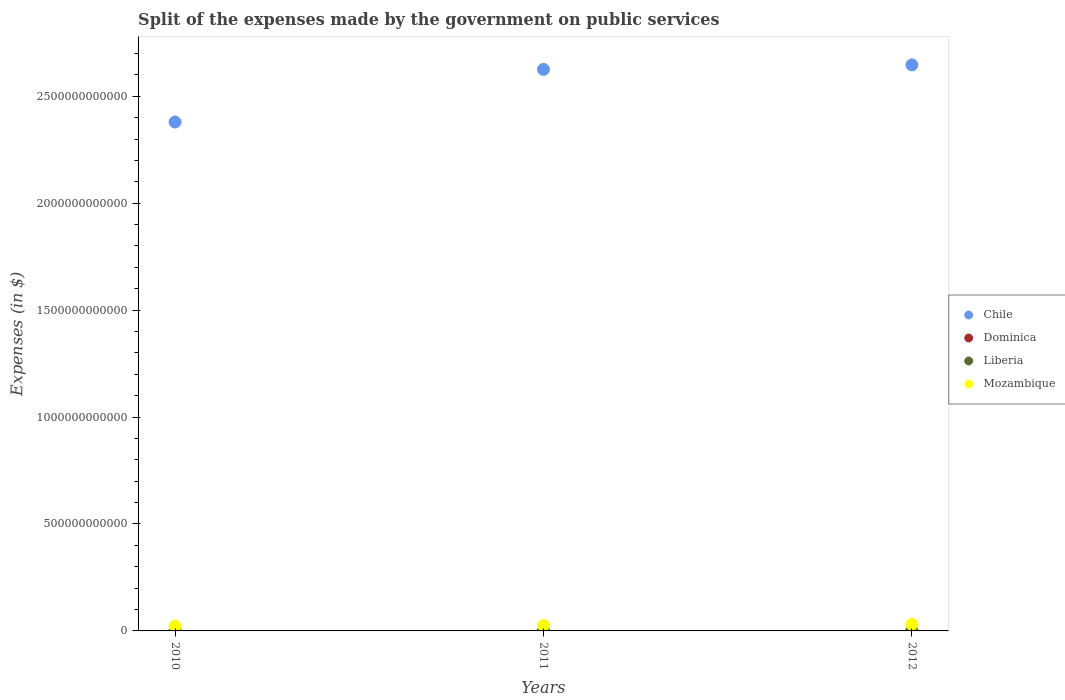Is the number of dotlines equal to the number of legend labels?
Offer a very short reply. Yes. What is the expenses made by the government on public services in Chile in 2012?
Offer a very short reply. 2.65e+12. Across all years, what is the maximum expenses made by the government on public services in Chile?
Give a very brief answer. 2.65e+12. Across all years, what is the minimum expenses made by the government on public services in Dominica?
Your answer should be compact. 9.19e+07. In which year was the expenses made by the government on public services in Dominica maximum?
Provide a succinct answer. 2010. What is the total expenses made by the government on public services in Dominica in the graph?
Provide a succinct answer. 2.88e+08. What is the difference between the expenses made by the government on public services in Mozambique in 2010 and that in 2012?
Your answer should be very brief. -8.15e+09. What is the difference between the expenses made by the government on public services in Liberia in 2011 and the expenses made by the government on public services in Chile in 2010?
Your response must be concise. -2.38e+12. What is the average expenses made by the government on public services in Dominica per year?
Give a very brief answer. 9.62e+07. In the year 2011, what is the difference between the expenses made by the government on public services in Chile and expenses made by the government on public services in Liberia?
Make the answer very short. 2.63e+12. In how many years, is the expenses made by the government on public services in Mozambique greater than 500000000000 $?
Your answer should be compact. 0. What is the ratio of the expenses made by the government on public services in Liberia in 2010 to that in 2011?
Your response must be concise. 0.83. Is the expenses made by the government on public services in Dominica in 2010 less than that in 2012?
Ensure brevity in your answer.  No. What is the difference between the highest and the second highest expenses made by the government on public services in Dominica?
Keep it short and to the point. 2.00e+06. What is the difference between the highest and the lowest expenses made by the government on public services in Liberia?
Keep it short and to the point. 6.64e+05. In how many years, is the expenses made by the government on public services in Liberia greater than the average expenses made by the government on public services in Liberia taken over all years?
Your answer should be compact. 1. Is it the case that in every year, the sum of the expenses made by the government on public services in Mozambique and expenses made by the government on public services in Chile  is greater than the sum of expenses made by the government on public services in Dominica and expenses made by the government on public services in Liberia?
Make the answer very short. Yes. Does the expenses made by the government on public services in Chile monotonically increase over the years?
Give a very brief answer. Yes. Is the expenses made by the government on public services in Chile strictly greater than the expenses made by the government on public services in Liberia over the years?
Make the answer very short. Yes. Is the expenses made by the government on public services in Liberia strictly less than the expenses made by the government on public services in Mozambique over the years?
Your answer should be very brief. Yes. How many dotlines are there?
Give a very brief answer. 4. How many years are there in the graph?
Make the answer very short. 3. What is the difference between two consecutive major ticks on the Y-axis?
Offer a terse response. 5.00e+11. Does the graph contain grids?
Offer a very short reply. No. Where does the legend appear in the graph?
Keep it short and to the point. Center right. How many legend labels are there?
Offer a terse response. 4. What is the title of the graph?
Your answer should be very brief. Split of the expenses made by the government on public services. Does "Fragile and conflict affected situations" appear as one of the legend labels in the graph?
Make the answer very short. No. What is the label or title of the Y-axis?
Offer a terse response. Expenses (in $). What is the Expenses (in $) of Chile in 2010?
Provide a succinct answer. 2.38e+12. What is the Expenses (in $) in Dominica in 2010?
Ensure brevity in your answer.  9.93e+07. What is the Expenses (in $) of Liberia in 2010?
Offer a terse response. 9.82e+05. What is the Expenses (in $) of Mozambique in 2010?
Your answer should be very brief. 2.24e+1. What is the Expenses (in $) in Chile in 2011?
Provide a short and direct response. 2.63e+12. What is the Expenses (in $) in Dominica in 2011?
Your response must be concise. 9.73e+07. What is the Expenses (in $) of Liberia in 2011?
Give a very brief answer. 1.19e+06. What is the Expenses (in $) in Mozambique in 2011?
Keep it short and to the point. 2.52e+1. What is the Expenses (in $) in Chile in 2012?
Make the answer very short. 2.65e+12. What is the Expenses (in $) in Dominica in 2012?
Offer a very short reply. 9.19e+07. What is the Expenses (in $) of Liberia in 2012?
Your answer should be compact. 1.65e+06. What is the Expenses (in $) of Mozambique in 2012?
Give a very brief answer. 3.05e+1. Across all years, what is the maximum Expenses (in $) of Chile?
Offer a terse response. 2.65e+12. Across all years, what is the maximum Expenses (in $) of Dominica?
Provide a short and direct response. 9.93e+07. Across all years, what is the maximum Expenses (in $) of Liberia?
Give a very brief answer. 1.65e+06. Across all years, what is the maximum Expenses (in $) in Mozambique?
Provide a succinct answer. 3.05e+1. Across all years, what is the minimum Expenses (in $) in Chile?
Your answer should be compact. 2.38e+12. Across all years, what is the minimum Expenses (in $) of Dominica?
Give a very brief answer. 9.19e+07. Across all years, what is the minimum Expenses (in $) of Liberia?
Offer a very short reply. 9.82e+05. Across all years, what is the minimum Expenses (in $) of Mozambique?
Offer a terse response. 2.24e+1. What is the total Expenses (in $) of Chile in the graph?
Your answer should be very brief. 7.65e+12. What is the total Expenses (in $) of Dominica in the graph?
Provide a succinct answer. 2.88e+08. What is the total Expenses (in $) in Liberia in the graph?
Ensure brevity in your answer.  3.81e+06. What is the total Expenses (in $) of Mozambique in the graph?
Provide a succinct answer. 7.81e+1. What is the difference between the Expenses (in $) of Chile in 2010 and that in 2011?
Offer a very short reply. -2.46e+11. What is the difference between the Expenses (in $) of Dominica in 2010 and that in 2011?
Give a very brief answer. 2.00e+06. What is the difference between the Expenses (in $) in Liberia in 2010 and that in 2011?
Offer a very short reply. -2.03e+05. What is the difference between the Expenses (in $) of Mozambique in 2010 and that in 2011?
Your response must be concise. -2.84e+09. What is the difference between the Expenses (in $) of Chile in 2010 and that in 2012?
Provide a short and direct response. -2.67e+11. What is the difference between the Expenses (in $) in Dominica in 2010 and that in 2012?
Make the answer very short. 7.40e+06. What is the difference between the Expenses (in $) of Liberia in 2010 and that in 2012?
Offer a very short reply. -6.64e+05. What is the difference between the Expenses (in $) of Mozambique in 2010 and that in 2012?
Offer a very short reply. -8.15e+09. What is the difference between the Expenses (in $) in Chile in 2011 and that in 2012?
Your response must be concise. -2.11e+1. What is the difference between the Expenses (in $) in Dominica in 2011 and that in 2012?
Make the answer very short. 5.40e+06. What is the difference between the Expenses (in $) of Liberia in 2011 and that in 2012?
Offer a terse response. -4.61e+05. What is the difference between the Expenses (in $) in Mozambique in 2011 and that in 2012?
Your response must be concise. -5.32e+09. What is the difference between the Expenses (in $) in Chile in 2010 and the Expenses (in $) in Dominica in 2011?
Ensure brevity in your answer.  2.38e+12. What is the difference between the Expenses (in $) of Chile in 2010 and the Expenses (in $) of Liberia in 2011?
Your answer should be very brief. 2.38e+12. What is the difference between the Expenses (in $) in Chile in 2010 and the Expenses (in $) in Mozambique in 2011?
Offer a very short reply. 2.35e+12. What is the difference between the Expenses (in $) of Dominica in 2010 and the Expenses (in $) of Liberia in 2011?
Your answer should be compact. 9.81e+07. What is the difference between the Expenses (in $) of Dominica in 2010 and the Expenses (in $) of Mozambique in 2011?
Provide a short and direct response. -2.51e+1. What is the difference between the Expenses (in $) in Liberia in 2010 and the Expenses (in $) in Mozambique in 2011?
Keep it short and to the point. -2.52e+1. What is the difference between the Expenses (in $) of Chile in 2010 and the Expenses (in $) of Dominica in 2012?
Your answer should be compact. 2.38e+12. What is the difference between the Expenses (in $) in Chile in 2010 and the Expenses (in $) in Liberia in 2012?
Your response must be concise. 2.38e+12. What is the difference between the Expenses (in $) of Chile in 2010 and the Expenses (in $) of Mozambique in 2012?
Make the answer very short. 2.35e+12. What is the difference between the Expenses (in $) in Dominica in 2010 and the Expenses (in $) in Liberia in 2012?
Provide a succinct answer. 9.77e+07. What is the difference between the Expenses (in $) in Dominica in 2010 and the Expenses (in $) in Mozambique in 2012?
Your response must be concise. -3.04e+1. What is the difference between the Expenses (in $) of Liberia in 2010 and the Expenses (in $) of Mozambique in 2012?
Ensure brevity in your answer.  -3.05e+1. What is the difference between the Expenses (in $) of Chile in 2011 and the Expenses (in $) of Dominica in 2012?
Make the answer very short. 2.63e+12. What is the difference between the Expenses (in $) of Chile in 2011 and the Expenses (in $) of Liberia in 2012?
Provide a short and direct response. 2.63e+12. What is the difference between the Expenses (in $) in Chile in 2011 and the Expenses (in $) in Mozambique in 2012?
Give a very brief answer. 2.60e+12. What is the difference between the Expenses (in $) in Dominica in 2011 and the Expenses (in $) in Liberia in 2012?
Make the answer very short. 9.57e+07. What is the difference between the Expenses (in $) in Dominica in 2011 and the Expenses (in $) in Mozambique in 2012?
Provide a succinct answer. -3.04e+1. What is the difference between the Expenses (in $) of Liberia in 2011 and the Expenses (in $) of Mozambique in 2012?
Provide a succinct answer. -3.05e+1. What is the average Expenses (in $) in Chile per year?
Your response must be concise. 2.55e+12. What is the average Expenses (in $) of Dominica per year?
Offer a terse response. 9.62e+07. What is the average Expenses (in $) of Liberia per year?
Your answer should be very brief. 1.27e+06. What is the average Expenses (in $) of Mozambique per year?
Give a very brief answer. 2.60e+1. In the year 2010, what is the difference between the Expenses (in $) in Chile and Expenses (in $) in Dominica?
Ensure brevity in your answer.  2.38e+12. In the year 2010, what is the difference between the Expenses (in $) of Chile and Expenses (in $) of Liberia?
Offer a terse response. 2.38e+12. In the year 2010, what is the difference between the Expenses (in $) in Chile and Expenses (in $) in Mozambique?
Give a very brief answer. 2.36e+12. In the year 2010, what is the difference between the Expenses (in $) in Dominica and Expenses (in $) in Liberia?
Your response must be concise. 9.83e+07. In the year 2010, what is the difference between the Expenses (in $) in Dominica and Expenses (in $) in Mozambique?
Offer a terse response. -2.23e+1. In the year 2010, what is the difference between the Expenses (in $) of Liberia and Expenses (in $) of Mozambique?
Offer a terse response. -2.24e+1. In the year 2011, what is the difference between the Expenses (in $) in Chile and Expenses (in $) in Dominica?
Keep it short and to the point. 2.63e+12. In the year 2011, what is the difference between the Expenses (in $) of Chile and Expenses (in $) of Liberia?
Provide a short and direct response. 2.63e+12. In the year 2011, what is the difference between the Expenses (in $) of Chile and Expenses (in $) of Mozambique?
Keep it short and to the point. 2.60e+12. In the year 2011, what is the difference between the Expenses (in $) in Dominica and Expenses (in $) in Liberia?
Provide a short and direct response. 9.61e+07. In the year 2011, what is the difference between the Expenses (in $) of Dominica and Expenses (in $) of Mozambique?
Your answer should be compact. -2.51e+1. In the year 2011, what is the difference between the Expenses (in $) of Liberia and Expenses (in $) of Mozambique?
Ensure brevity in your answer.  -2.52e+1. In the year 2012, what is the difference between the Expenses (in $) of Chile and Expenses (in $) of Dominica?
Provide a succinct answer. 2.65e+12. In the year 2012, what is the difference between the Expenses (in $) in Chile and Expenses (in $) in Liberia?
Ensure brevity in your answer.  2.65e+12. In the year 2012, what is the difference between the Expenses (in $) of Chile and Expenses (in $) of Mozambique?
Ensure brevity in your answer.  2.62e+12. In the year 2012, what is the difference between the Expenses (in $) of Dominica and Expenses (in $) of Liberia?
Provide a short and direct response. 9.03e+07. In the year 2012, what is the difference between the Expenses (in $) of Dominica and Expenses (in $) of Mozambique?
Ensure brevity in your answer.  -3.04e+1. In the year 2012, what is the difference between the Expenses (in $) in Liberia and Expenses (in $) in Mozambique?
Offer a terse response. -3.05e+1. What is the ratio of the Expenses (in $) in Chile in 2010 to that in 2011?
Provide a short and direct response. 0.91. What is the ratio of the Expenses (in $) of Dominica in 2010 to that in 2011?
Your answer should be very brief. 1.02. What is the ratio of the Expenses (in $) of Liberia in 2010 to that in 2011?
Your response must be concise. 0.83. What is the ratio of the Expenses (in $) in Mozambique in 2010 to that in 2011?
Your answer should be very brief. 0.89. What is the ratio of the Expenses (in $) in Chile in 2010 to that in 2012?
Give a very brief answer. 0.9. What is the ratio of the Expenses (in $) in Dominica in 2010 to that in 2012?
Your response must be concise. 1.08. What is the ratio of the Expenses (in $) in Liberia in 2010 to that in 2012?
Give a very brief answer. 0.6. What is the ratio of the Expenses (in $) in Mozambique in 2010 to that in 2012?
Offer a terse response. 0.73. What is the ratio of the Expenses (in $) of Chile in 2011 to that in 2012?
Your answer should be very brief. 0.99. What is the ratio of the Expenses (in $) in Dominica in 2011 to that in 2012?
Provide a succinct answer. 1.06. What is the ratio of the Expenses (in $) of Liberia in 2011 to that in 2012?
Give a very brief answer. 0.72. What is the ratio of the Expenses (in $) in Mozambique in 2011 to that in 2012?
Your response must be concise. 0.83. What is the difference between the highest and the second highest Expenses (in $) of Chile?
Offer a terse response. 2.11e+1. What is the difference between the highest and the second highest Expenses (in $) of Dominica?
Your response must be concise. 2.00e+06. What is the difference between the highest and the second highest Expenses (in $) of Liberia?
Provide a short and direct response. 4.61e+05. What is the difference between the highest and the second highest Expenses (in $) of Mozambique?
Make the answer very short. 5.32e+09. What is the difference between the highest and the lowest Expenses (in $) in Chile?
Provide a succinct answer. 2.67e+11. What is the difference between the highest and the lowest Expenses (in $) in Dominica?
Your answer should be compact. 7.40e+06. What is the difference between the highest and the lowest Expenses (in $) of Liberia?
Give a very brief answer. 6.64e+05. What is the difference between the highest and the lowest Expenses (in $) in Mozambique?
Ensure brevity in your answer.  8.15e+09. 